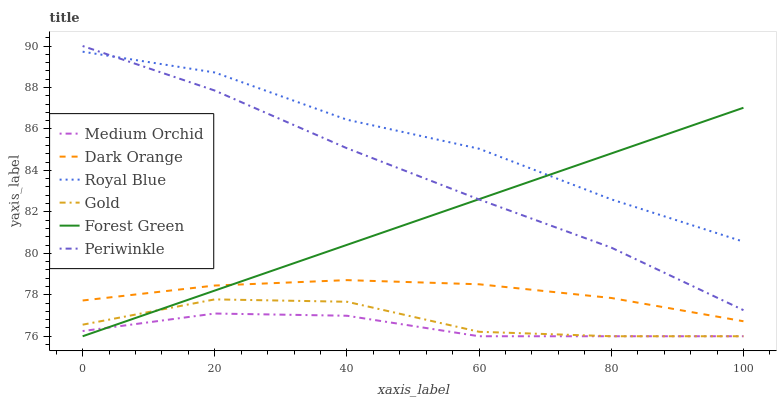Does Medium Orchid have the minimum area under the curve?
Answer yes or no. Yes. Does Royal Blue have the maximum area under the curve?
Answer yes or no. Yes. Does Gold have the minimum area under the curve?
Answer yes or no. No. Does Gold have the maximum area under the curve?
Answer yes or no. No. Is Forest Green the smoothest?
Answer yes or no. Yes. Is Gold the roughest?
Answer yes or no. Yes. Is Medium Orchid the smoothest?
Answer yes or no. No. Is Medium Orchid the roughest?
Answer yes or no. No. Does Gold have the lowest value?
Answer yes or no. Yes. Does Royal Blue have the lowest value?
Answer yes or no. No. Does Periwinkle have the highest value?
Answer yes or no. Yes. Does Gold have the highest value?
Answer yes or no. No. Is Dark Orange less than Royal Blue?
Answer yes or no. Yes. Is Royal Blue greater than Gold?
Answer yes or no. Yes. Does Gold intersect Medium Orchid?
Answer yes or no. Yes. Is Gold less than Medium Orchid?
Answer yes or no. No. Is Gold greater than Medium Orchid?
Answer yes or no. No. Does Dark Orange intersect Royal Blue?
Answer yes or no. No. 